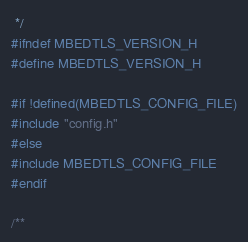Convert code to text. <code><loc_0><loc_0><loc_500><loc_500><_C_> */
#ifndef MBEDTLS_VERSION_H
#define MBEDTLS_VERSION_H

#if !defined(MBEDTLS_CONFIG_FILE)
#include "config.h"
#else
#include MBEDTLS_CONFIG_FILE
#endif

/**</code> 